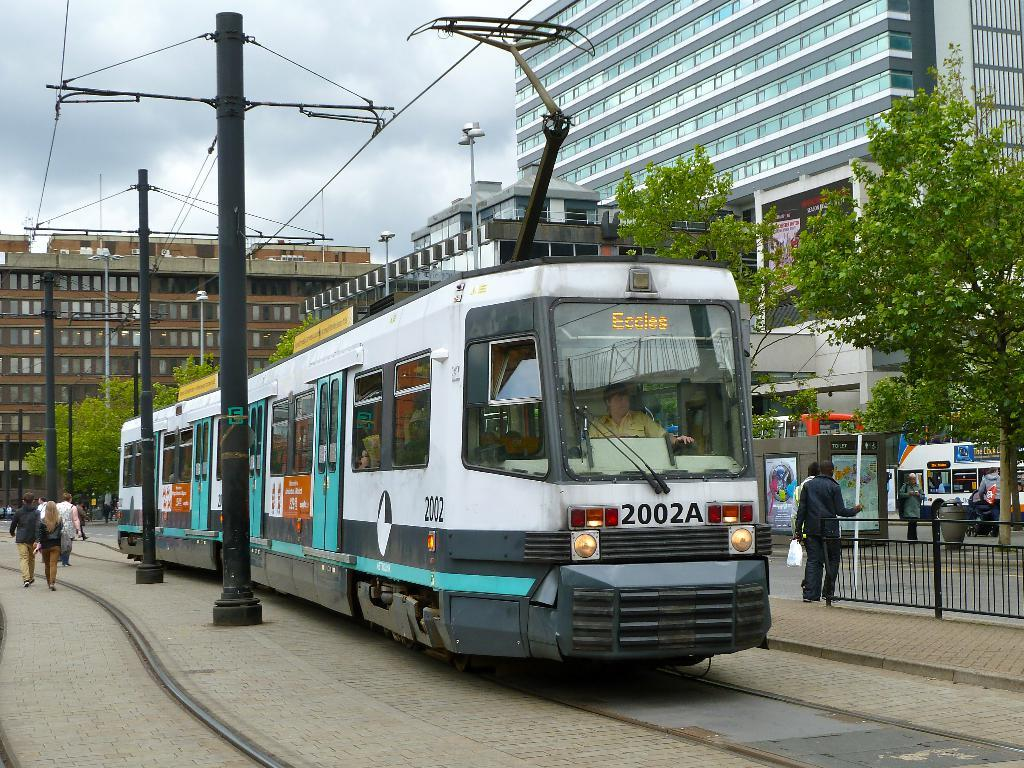<image>
Describe the image concisely. the letter 2002a that is on front of a train 